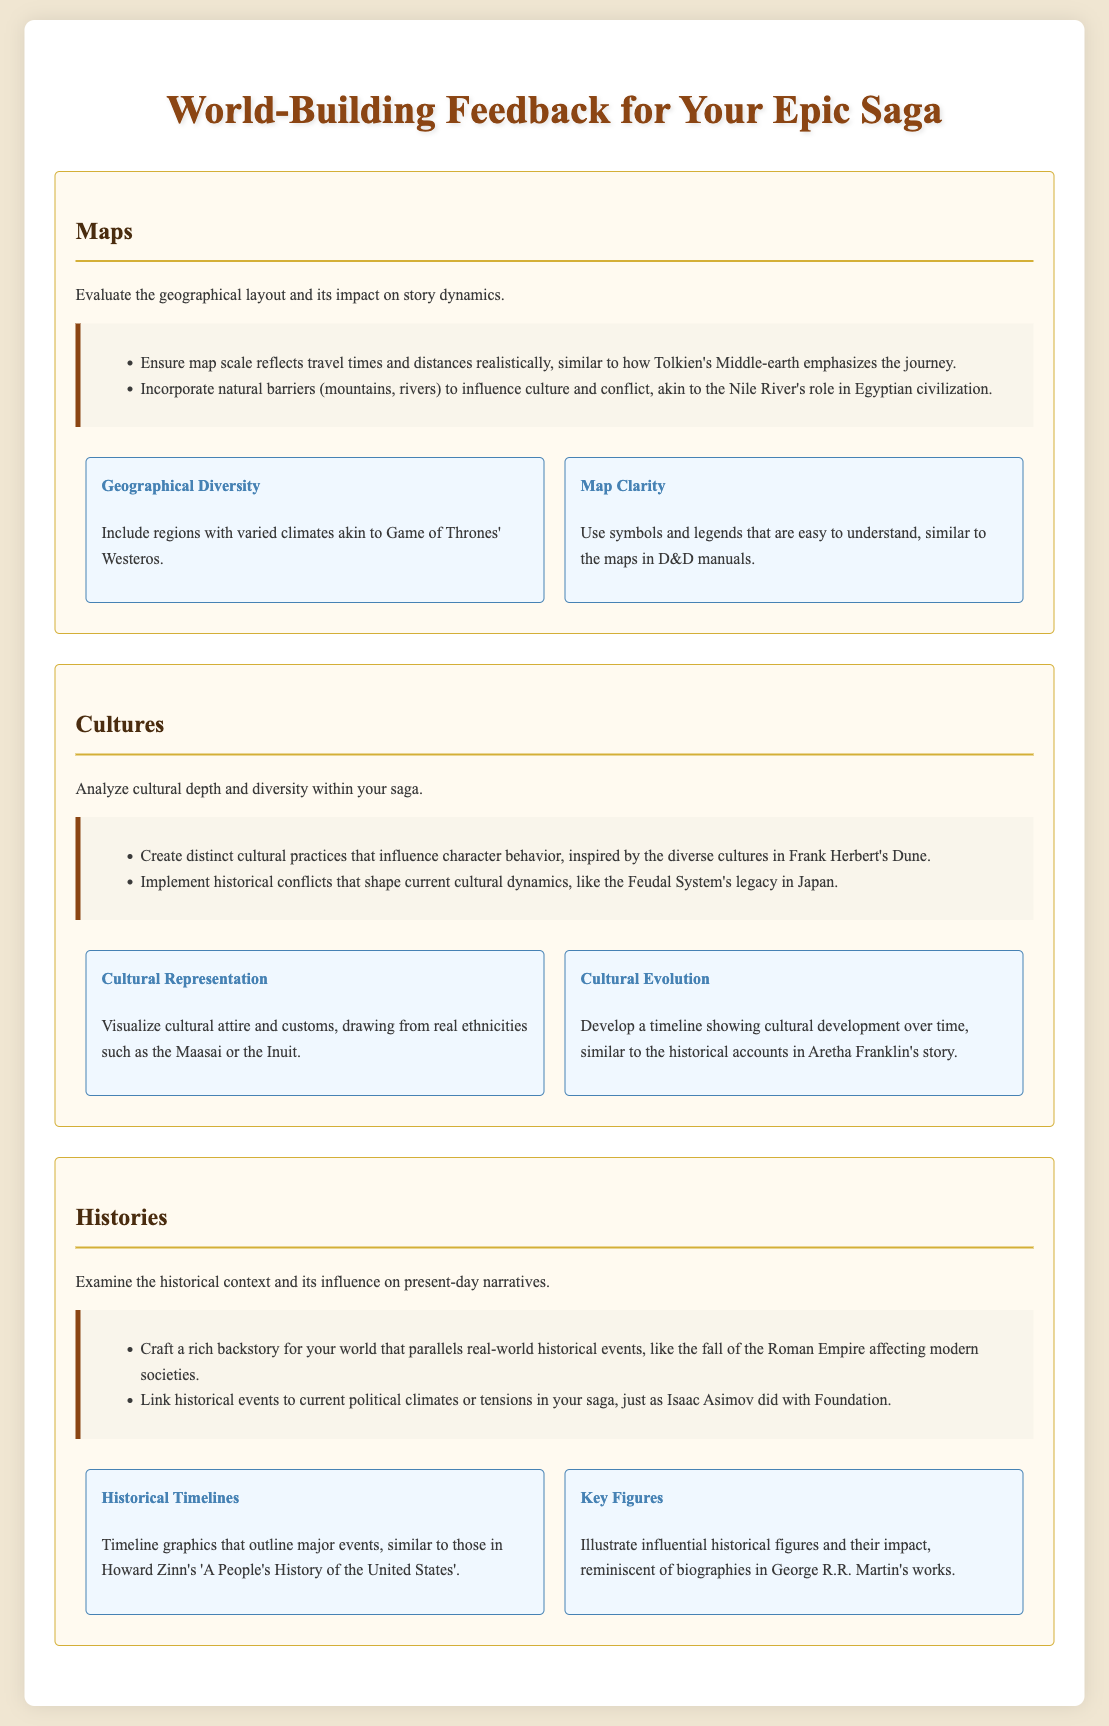What are the two main elements evaluated in the Maps section? The Maps section evaluates the geographical layout and its impact on story dynamics.
Answer: geographical layout, story dynamics Which literary work is referenced in connection with cultural representation? The document suggests using real ethnicities for cultural attire and customs, citing the Maasai or the Inuit.
Answer: Maasai, Inuit What historical feature does the document suggest including to influence character behavior? The feedback section on Cultures emphasizes that distinct cultural practices influence character behavior.
Answer: distinct cultural practices In the Histories section, what type of graphics does it recommend for outlining major events? The document suggests using timeline graphics to outline major events, similar to those in Howard Zinn's work.
Answer: timeline graphics According to the feedback, which world-building aspect can natural barriers influence? The document indicates that natural barriers, like mountains and rivers, can influence culture and conflict.
Answer: culture and conflict What specific element should be included to enhance map clarity, according to the document? The visual aids for Maps recommend using symbols and legends that are easy to understand for better clarity.
Answer: symbols and legends Which work is mentioned regarding the linking of historical events to current political climates? The document references Isaac Asimov's work with Foundation concerning this linkage.
Answer: Foundation In the visual aids for Cultures, what does the section on Cultural Evolution suggest visualizing? The document recommends developing a timeline showing cultural development over time for Cultural Evolution.
Answer: timeline showing cultural development 